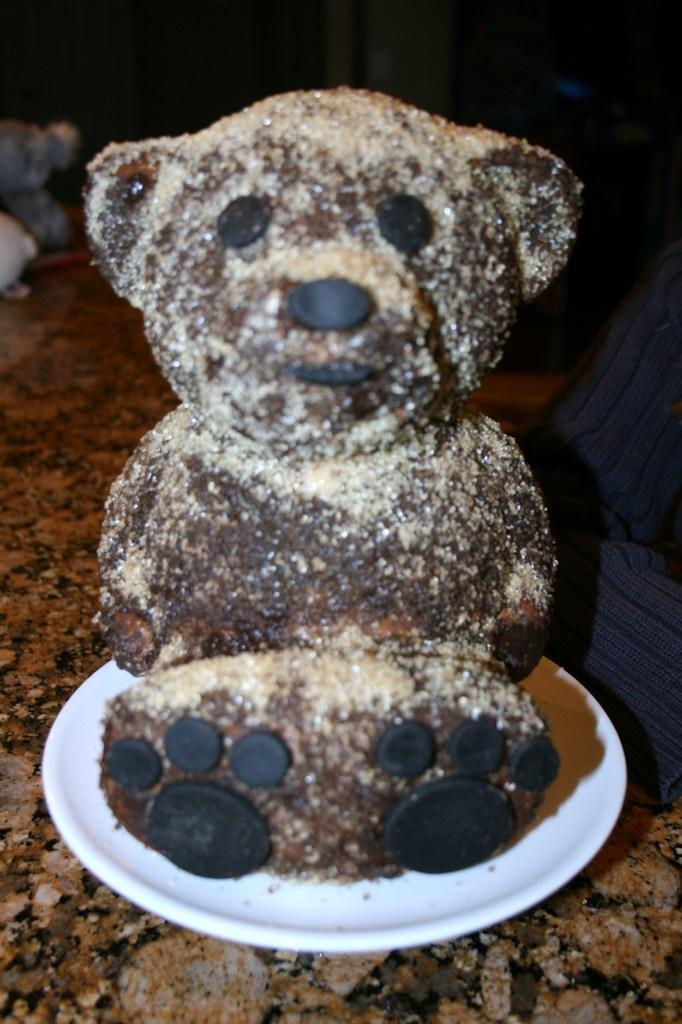What is on the plate that is visible in the image? The plate contains a chocolate in the shape of a teddy bear. What else can be seen in the image besides the plate? There is a person's hand on the right side of the image. What is the surface visible at the bottom of the image? There is a floor visible at the bottom of the image. How many geese are present on the ground in the image? There are no geese present in the image; it only features a plate with a chocolate teddy bear, a person's hand, and a floor. 